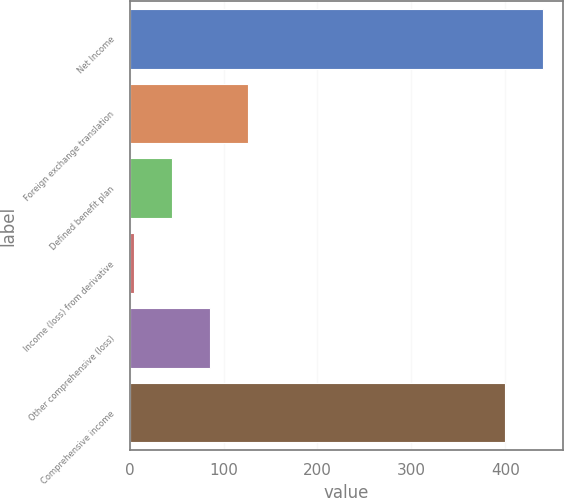<chart> <loc_0><loc_0><loc_500><loc_500><bar_chart><fcel>Net Income<fcel>Foreign exchange translation<fcel>Defined benefit plan<fcel>Income (loss) from derivative<fcel>Other comprehensive (loss)<fcel>Comprehensive income<nl><fcel>439.77<fcel>126.41<fcel>45.27<fcel>4.7<fcel>85.84<fcel>399.2<nl></chart> 